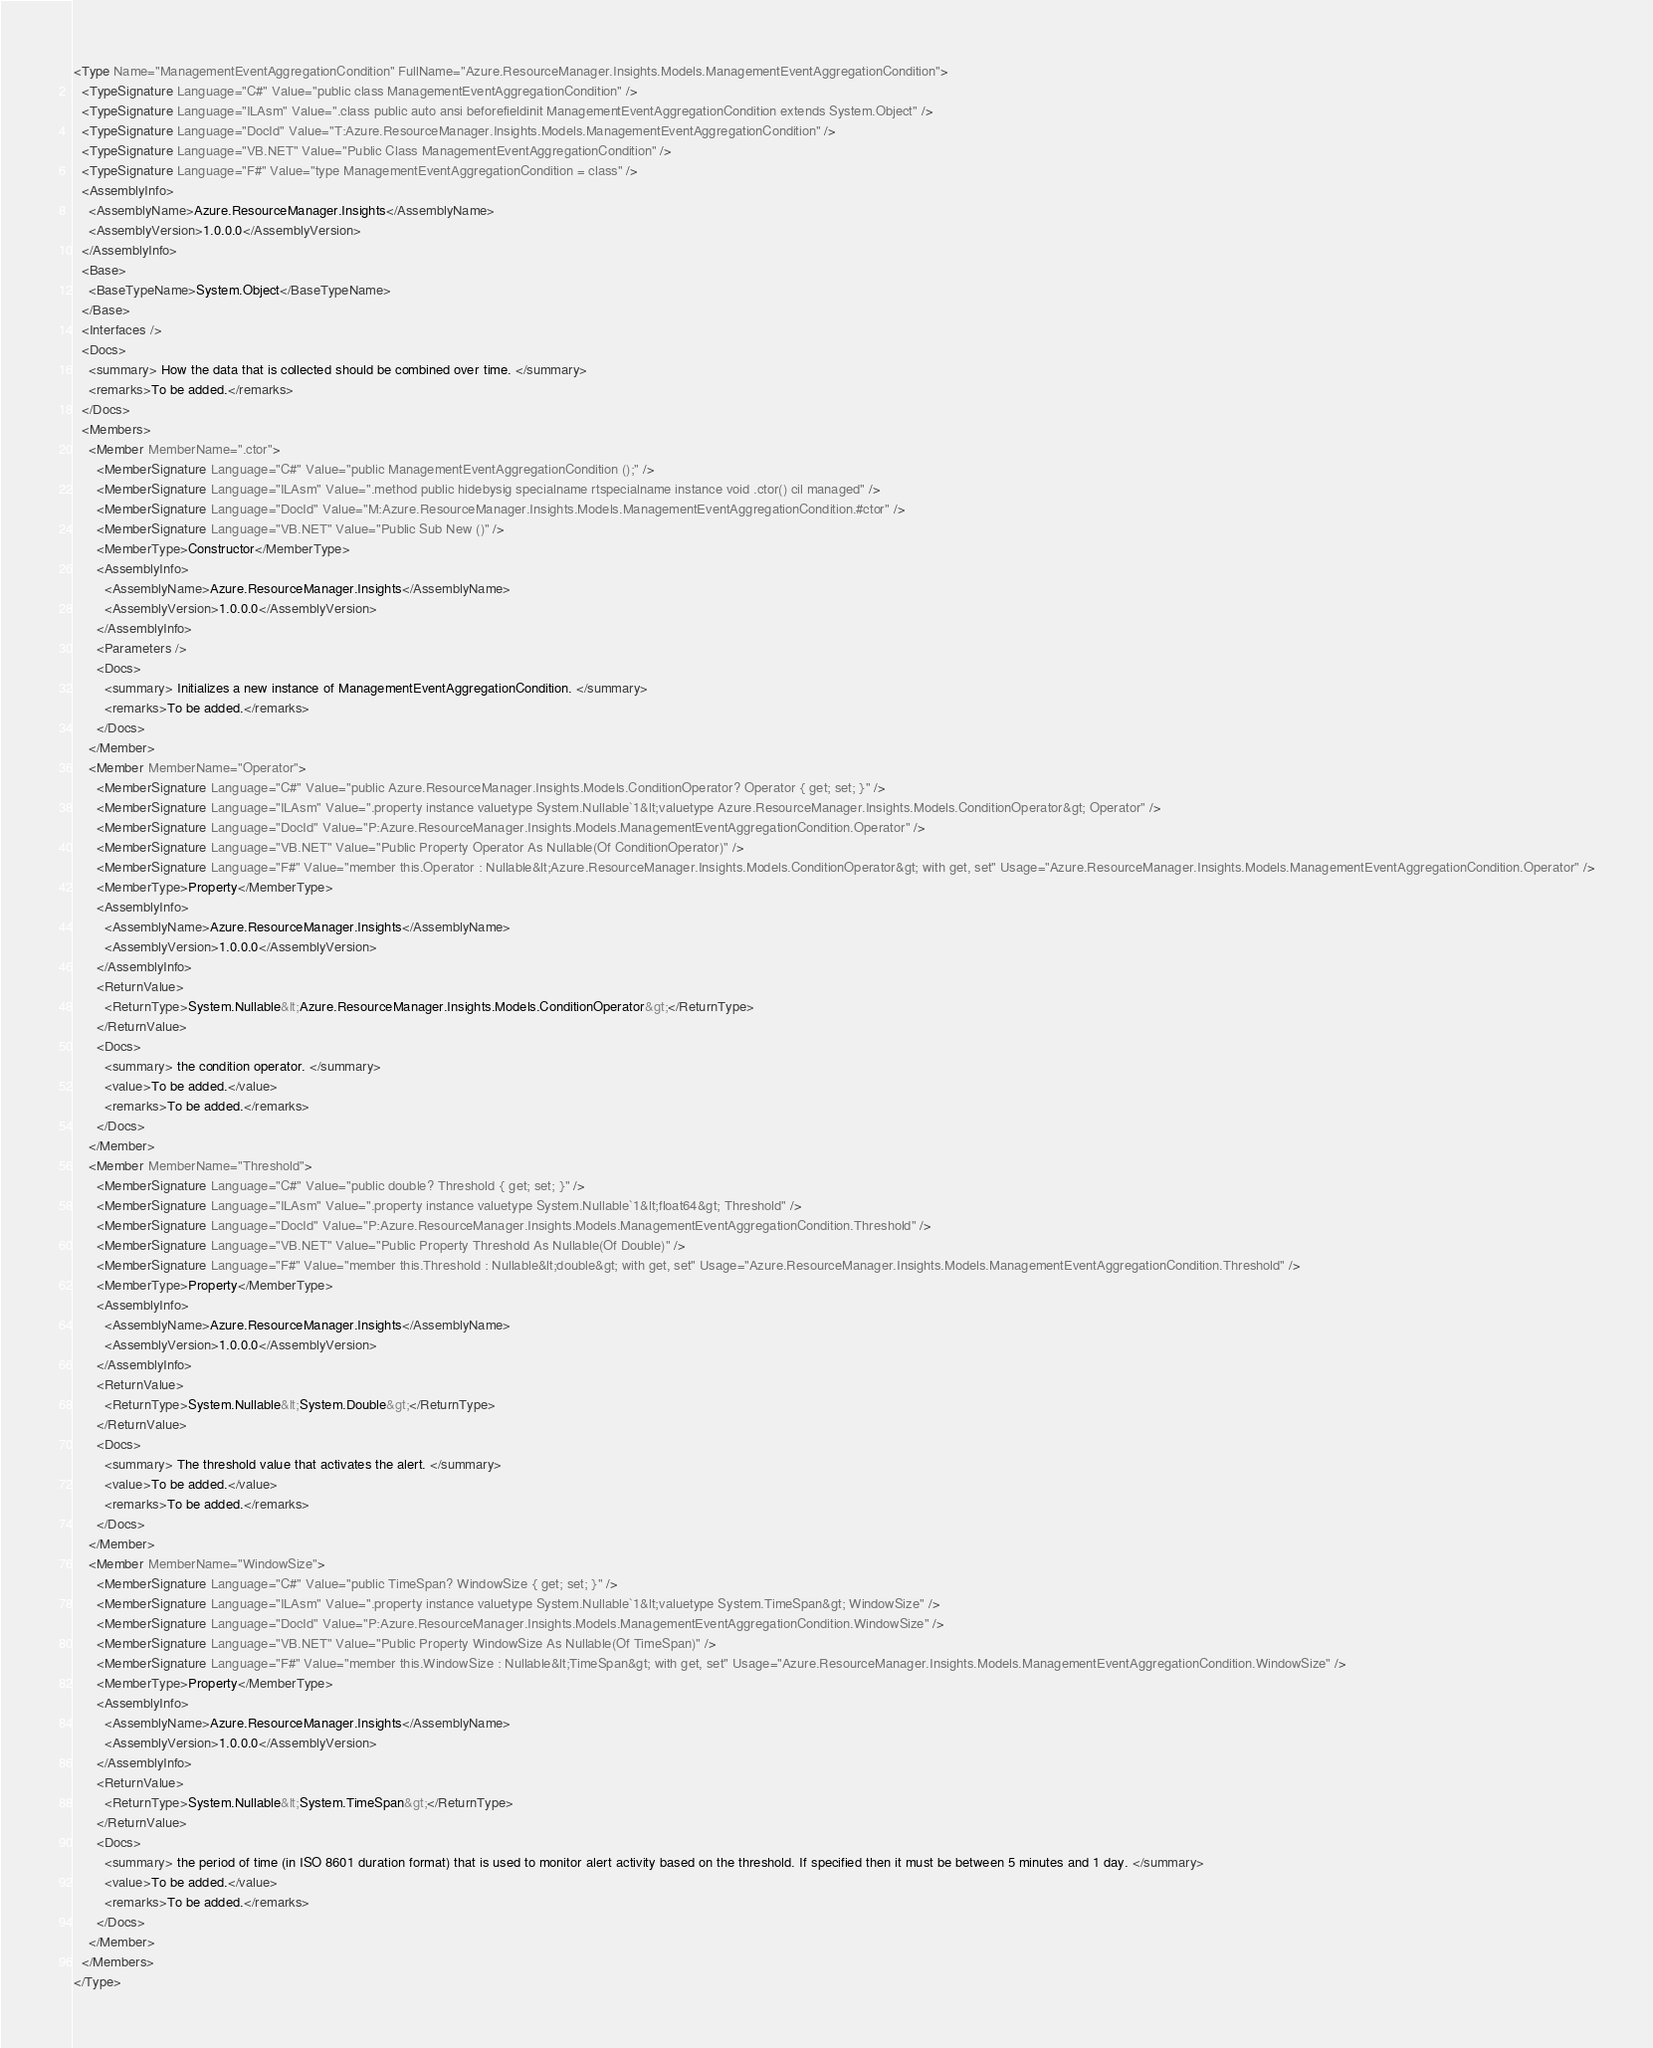Convert code to text. <code><loc_0><loc_0><loc_500><loc_500><_XML_><Type Name="ManagementEventAggregationCondition" FullName="Azure.ResourceManager.Insights.Models.ManagementEventAggregationCondition">
  <TypeSignature Language="C#" Value="public class ManagementEventAggregationCondition" />
  <TypeSignature Language="ILAsm" Value=".class public auto ansi beforefieldinit ManagementEventAggregationCondition extends System.Object" />
  <TypeSignature Language="DocId" Value="T:Azure.ResourceManager.Insights.Models.ManagementEventAggregationCondition" />
  <TypeSignature Language="VB.NET" Value="Public Class ManagementEventAggregationCondition" />
  <TypeSignature Language="F#" Value="type ManagementEventAggregationCondition = class" />
  <AssemblyInfo>
    <AssemblyName>Azure.ResourceManager.Insights</AssemblyName>
    <AssemblyVersion>1.0.0.0</AssemblyVersion>
  </AssemblyInfo>
  <Base>
    <BaseTypeName>System.Object</BaseTypeName>
  </Base>
  <Interfaces />
  <Docs>
    <summary> How the data that is collected should be combined over time. </summary>
    <remarks>To be added.</remarks>
  </Docs>
  <Members>
    <Member MemberName=".ctor">
      <MemberSignature Language="C#" Value="public ManagementEventAggregationCondition ();" />
      <MemberSignature Language="ILAsm" Value=".method public hidebysig specialname rtspecialname instance void .ctor() cil managed" />
      <MemberSignature Language="DocId" Value="M:Azure.ResourceManager.Insights.Models.ManagementEventAggregationCondition.#ctor" />
      <MemberSignature Language="VB.NET" Value="Public Sub New ()" />
      <MemberType>Constructor</MemberType>
      <AssemblyInfo>
        <AssemblyName>Azure.ResourceManager.Insights</AssemblyName>
        <AssemblyVersion>1.0.0.0</AssemblyVersion>
      </AssemblyInfo>
      <Parameters />
      <Docs>
        <summary> Initializes a new instance of ManagementEventAggregationCondition. </summary>
        <remarks>To be added.</remarks>
      </Docs>
    </Member>
    <Member MemberName="Operator">
      <MemberSignature Language="C#" Value="public Azure.ResourceManager.Insights.Models.ConditionOperator? Operator { get; set; }" />
      <MemberSignature Language="ILAsm" Value=".property instance valuetype System.Nullable`1&lt;valuetype Azure.ResourceManager.Insights.Models.ConditionOperator&gt; Operator" />
      <MemberSignature Language="DocId" Value="P:Azure.ResourceManager.Insights.Models.ManagementEventAggregationCondition.Operator" />
      <MemberSignature Language="VB.NET" Value="Public Property Operator As Nullable(Of ConditionOperator)" />
      <MemberSignature Language="F#" Value="member this.Operator : Nullable&lt;Azure.ResourceManager.Insights.Models.ConditionOperator&gt; with get, set" Usage="Azure.ResourceManager.Insights.Models.ManagementEventAggregationCondition.Operator" />
      <MemberType>Property</MemberType>
      <AssemblyInfo>
        <AssemblyName>Azure.ResourceManager.Insights</AssemblyName>
        <AssemblyVersion>1.0.0.0</AssemblyVersion>
      </AssemblyInfo>
      <ReturnValue>
        <ReturnType>System.Nullable&lt;Azure.ResourceManager.Insights.Models.ConditionOperator&gt;</ReturnType>
      </ReturnValue>
      <Docs>
        <summary> the condition operator. </summary>
        <value>To be added.</value>
        <remarks>To be added.</remarks>
      </Docs>
    </Member>
    <Member MemberName="Threshold">
      <MemberSignature Language="C#" Value="public double? Threshold { get; set; }" />
      <MemberSignature Language="ILAsm" Value=".property instance valuetype System.Nullable`1&lt;float64&gt; Threshold" />
      <MemberSignature Language="DocId" Value="P:Azure.ResourceManager.Insights.Models.ManagementEventAggregationCondition.Threshold" />
      <MemberSignature Language="VB.NET" Value="Public Property Threshold As Nullable(Of Double)" />
      <MemberSignature Language="F#" Value="member this.Threshold : Nullable&lt;double&gt; with get, set" Usage="Azure.ResourceManager.Insights.Models.ManagementEventAggregationCondition.Threshold" />
      <MemberType>Property</MemberType>
      <AssemblyInfo>
        <AssemblyName>Azure.ResourceManager.Insights</AssemblyName>
        <AssemblyVersion>1.0.0.0</AssemblyVersion>
      </AssemblyInfo>
      <ReturnValue>
        <ReturnType>System.Nullable&lt;System.Double&gt;</ReturnType>
      </ReturnValue>
      <Docs>
        <summary> The threshold value that activates the alert. </summary>
        <value>To be added.</value>
        <remarks>To be added.</remarks>
      </Docs>
    </Member>
    <Member MemberName="WindowSize">
      <MemberSignature Language="C#" Value="public TimeSpan? WindowSize { get; set; }" />
      <MemberSignature Language="ILAsm" Value=".property instance valuetype System.Nullable`1&lt;valuetype System.TimeSpan&gt; WindowSize" />
      <MemberSignature Language="DocId" Value="P:Azure.ResourceManager.Insights.Models.ManagementEventAggregationCondition.WindowSize" />
      <MemberSignature Language="VB.NET" Value="Public Property WindowSize As Nullable(Of TimeSpan)" />
      <MemberSignature Language="F#" Value="member this.WindowSize : Nullable&lt;TimeSpan&gt; with get, set" Usage="Azure.ResourceManager.Insights.Models.ManagementEventAggregationCondition.WindowSize" />
      <MemberType>Property</MemberType>
      <AssemblyInfo>
        <AssemblyName>Azure.ResourceManager.Insights</AssemblyName>
        <AssemblyVersion>1.0.0.0</AssemblyVersion>
      </AssemblyInfo>
      <ReturnValue>
        <ReturnType>System.Nullable&lt;System.TimeSpan&gt;</ReturnType>
      </ReturnValue>
      <Docs>
        <summary> the period of time (in ISO 8601 duration format) that is used to monitor alert activity based on the threshold. If specified then it must be between 5 minutes and 1 day. </summary>
        <value>To be added.</value>
        <remarks>To be added.</remarks>
      </Docs>
    </Member>
  </Members>
</Type>
</code> 